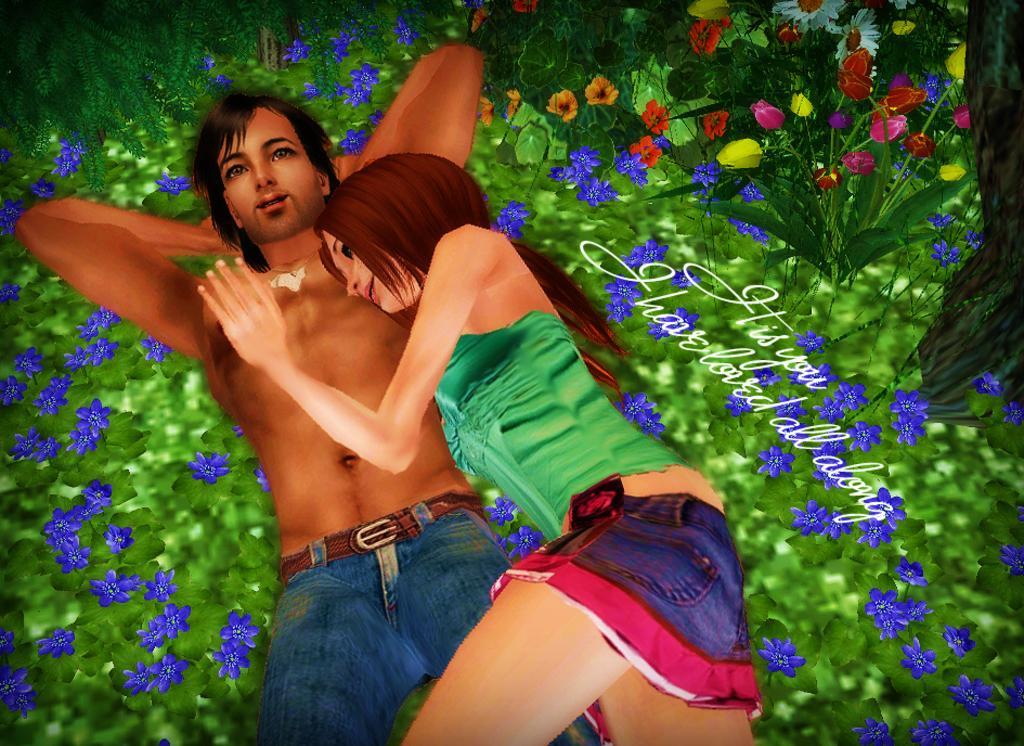Could you give a brief overview of what you see in this image? This is an animated image. In this image we can see a man and a woman lying on the ground. We can also see some plants with flowers and some text on this image. 